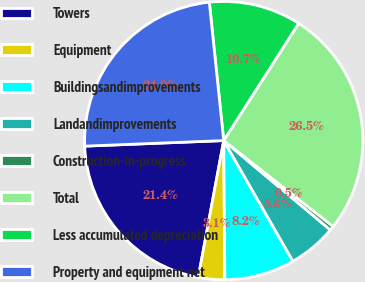<chart> <loc_0><loc_0><loc_500><loc_500><pie_chart><fcel>Towers<fcel>Equipment<fcel>Buildingsandimprovements<fcel>Landandimprovements<fcel>Construction-in-progress<fcel>Total<fcel>Less accumulated depreciation<fcel>Property and equipment net<nl><fcel>21.44%<fcel>3.06%<fcel>8.16%<fcel>5.61%<fcel>0.51%<fcel>26.54%<fcel>10.71%<fcel>23.99%<nl></chart> 